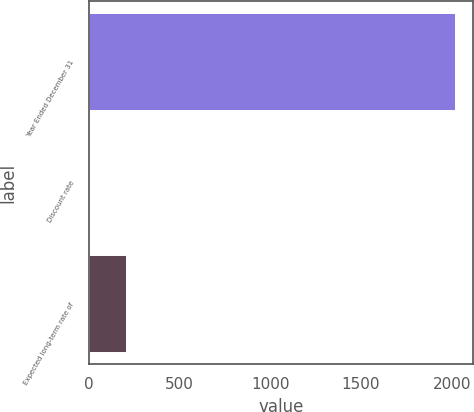Convert chart to OTSL. <chart><loc_0><loc_0><loc_500><loc_500><bar_chart><fcel>Year Ended December 31<fcel>Discount rate<fcel>Expected long-term rate of<nl><fcel>2016<fcel>4.25<fcel>205.43<nl></chart> 